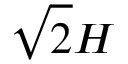Convert formula to latex. <formula><loc_0><loc_0><loc_500><loc_500>\sqrt { 2 } H</formula> 